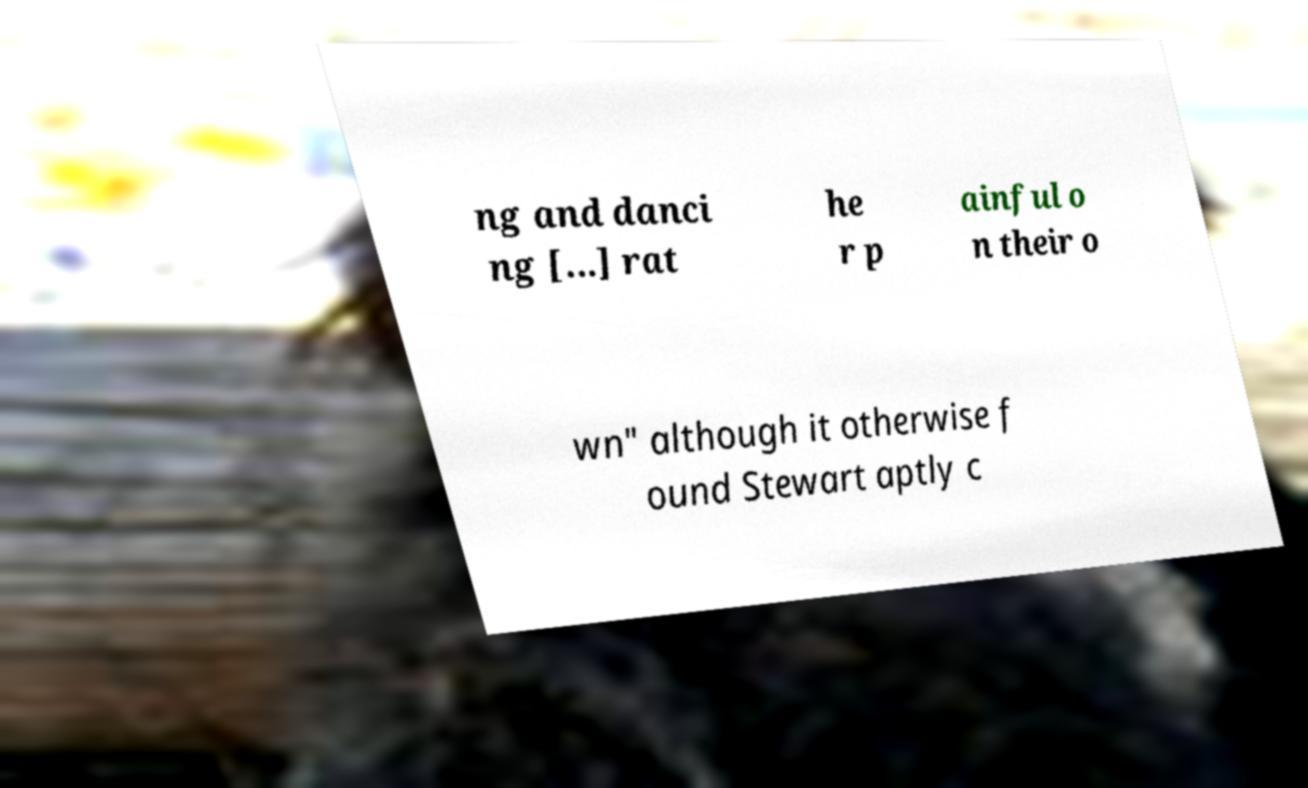What messages or text are displayed in this image? I need them in a readable, typed format. ng and danci ng [...] rat he r p ainful o n their o wn" although it otherwise f ound Stewart aptly c 